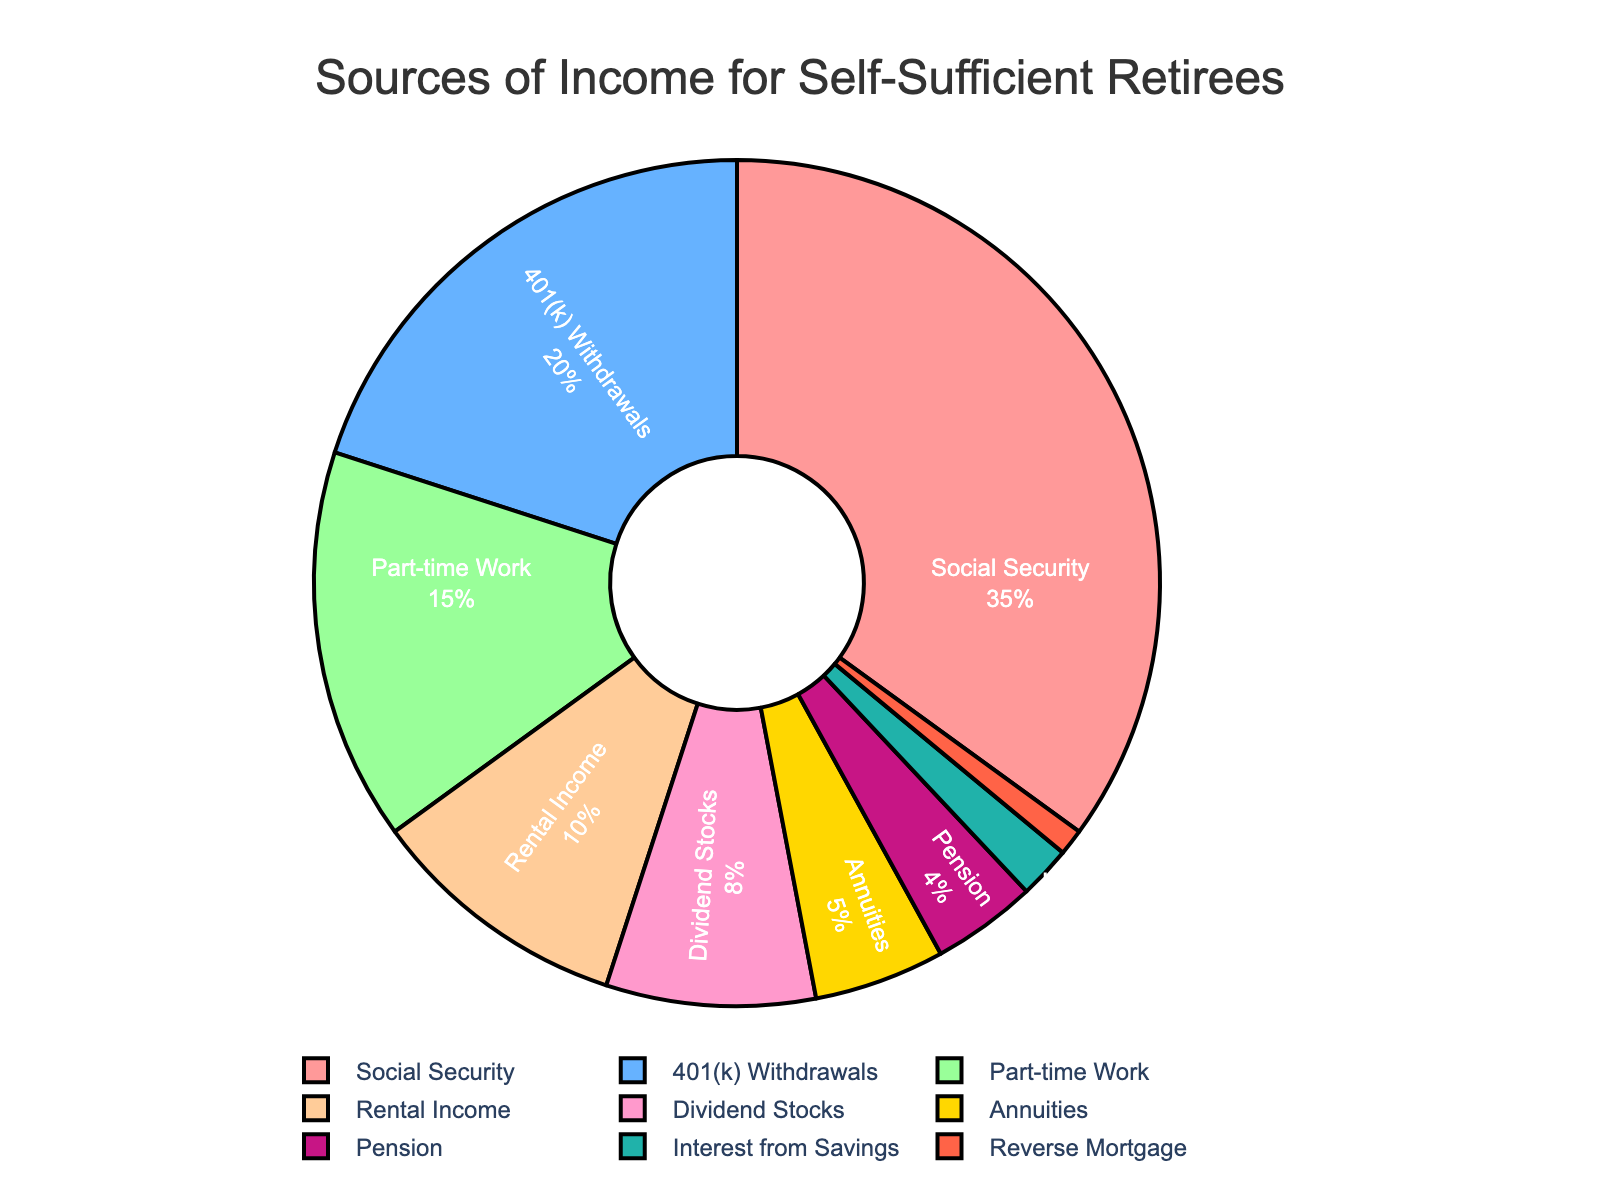What is the largest source of income for self-sufficient retirees? The largest source of income is the segment that occupies the biggest portion of the pie chart, which is Social Security at 35%.
Answer: Social Security What percentage of income comes from 401(k) Withdrawals and Dividend Stocks combined? Add the percentages for 401(k) Withdrawals (20%) and Dividend Stocks (8%). 20% + 8% = 28%
Answer: 28% Which source of income is greater: Rental Income or Annuities? By comparing the percentages, Rental Income is 10% and Annuities are 5%. Therefore, Rental Income is greater.
Answer: Rental Income How many income sources each account for less than 10% of total income? Identify the segments with percentages less than 10%: Dividend Stocks (8%), Annuities (5%), Pension (4%), Interest from Savings (2%), Reverse Mortgage (1%). Count these segments: 5 income sources.
Answer: 5 What is the difference in percentage between Social Security and Part-time Work? Subtract the percentage of Part-time Work (15%) from Social Security (35%). 35% - 15% = 20%
Answer: 20% Compare the contributions of Pension and Reverse Mortgage. Which has a smaller share and by how much? Pension is 4% and Reverse Mortgage is 1%, so Reverse Mortgage has a smaller share. The difference is 4% - 1% = 3%.
Answer: Reverse Mortgage by 3% Summarize the total percentage of income coming from three smallest sources. What are these categories? The three smallest sources are Pension (4%), Interest from Savings (2%), and Reverse Mortgage (1%). Sum these percentages: 4% + 2% + 1% = 7%.
Answer: 7% Which two income sources together make up a quarter of the total income? Find two segments that together total 25%. Part-time Work (15%) and Dividend Stocks (8%) sum to 23% which is close but not exact. Instead, Rental Income (10%) and Dividend Stocks (8%) together make 18%, still not 25%. The closest pairs do not add up precisely to 25%, so this problem reveals no exact match.
Answer: No exact match Which category is shown in a blue color? Visually identify the segment colored blue which is 401(k) Withdrawals.
Answer: 401(k) Withdrawals 